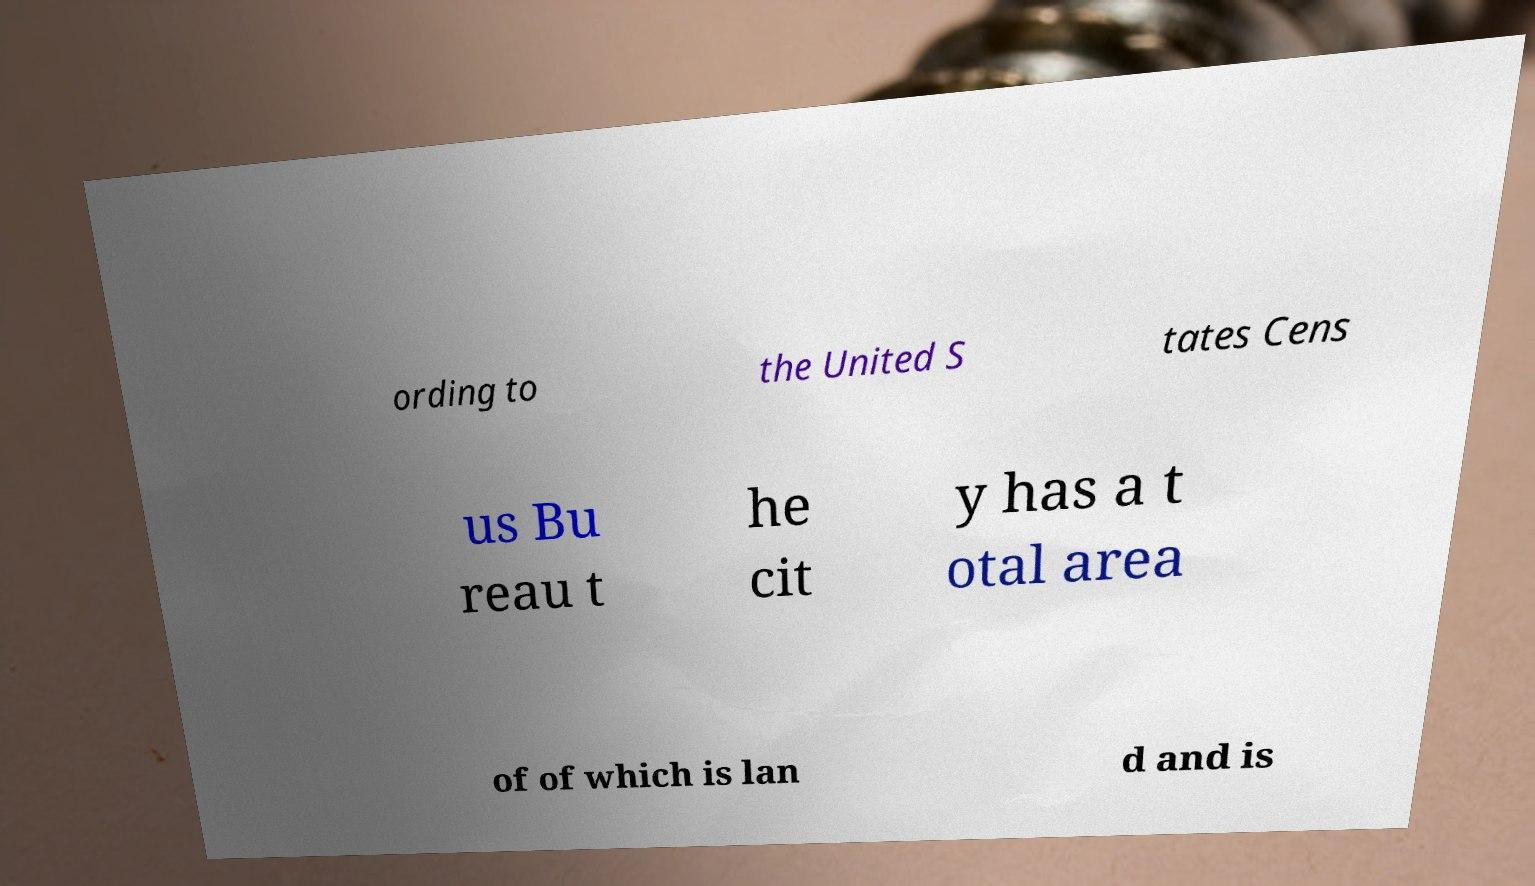What messages or text are displayed in this image? I need them in a readable, typed format. ording to the United S tates Cens us Bu reau t he cit y has a t otal area of of which is lan d and is 